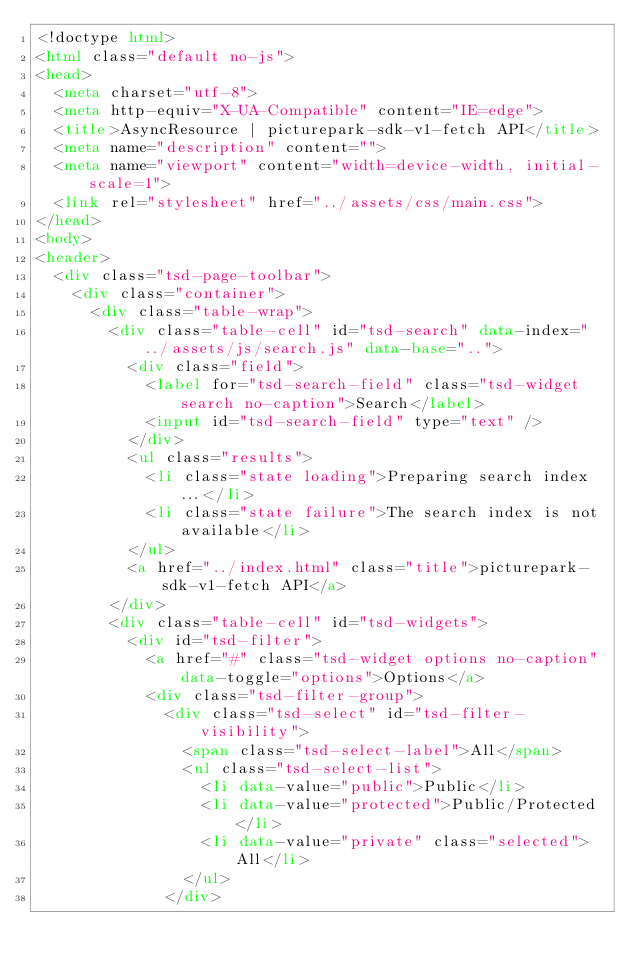Convert code to text. <code><loc_0><loc_0><loc_500><loc_500><_HTML_><!doctype html>
<html class="default no-js">
<head>
	<meta charset="utf-8">
	<meta http-equiv="X-UA-Compatible" content="IE=edge">
	<title>AsyncResource | picturepark-sdk-v1-fetch API</title>
	<meta name="description" content="">
	<meta name="viewport" content="width=device-width, initial-scale=1">
	<link rel="stylesheet" href="../assets/css/main.css">
</head>
<body>
<header>
	<div class="tsd-page-toolbar">
		<div class="container">
			<div class="table-wrap">
				<div class="table-cell" id="tsd-search" data-index="../assets/js/search.js" data-base="..">
					<div class="field">
						<label for="tsd-search-field" class="tsd-widget search no-caption">Search</label>
						<input id="tsd-search-field" type="text" />
					</div>
					<ul class="results">
						<li class="state loading">Preparing search index...</li>
						<li class="state failure">The search index is not available</li>
					</ul>
					<a href="../index.html" class="title">picturepark-sdk-v1-fetch API</a>
				</div>
				<div class="table-cell" id="tsd-widgets">
					<div id="tsd-filter">
						<a href="#" class="tsd-widget options no-caption" data-toggle="options">Options</a>
						<div class="tsd-filter-group">
							<div class="tsd-select" id="tsd-filter-visibility">
								<span class="tsd-select-label">All</span>
								<ul class="tsd-select-list">
									<li data-value="public">Public</li>
									<li data-value="protected">Public/Protected</li>
									<li data-value="private" class="selected">All</li>
								</ul>
							</div></code> 